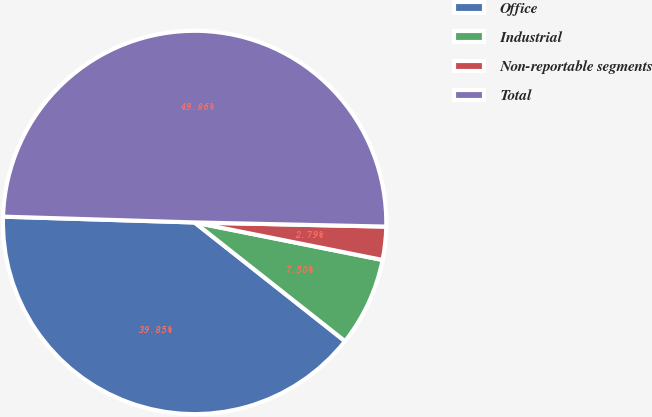<chart> <loc_0><loc_0><loc_500><loc_500><pie_chart><fcel>Office<fcel>Industrial<fcel>Non-reportable segments<fcel>Total<nl><fcel>39.85%<fcel>7.5%<fcel>2.79%<fcel>49.86%<nl></chart> 